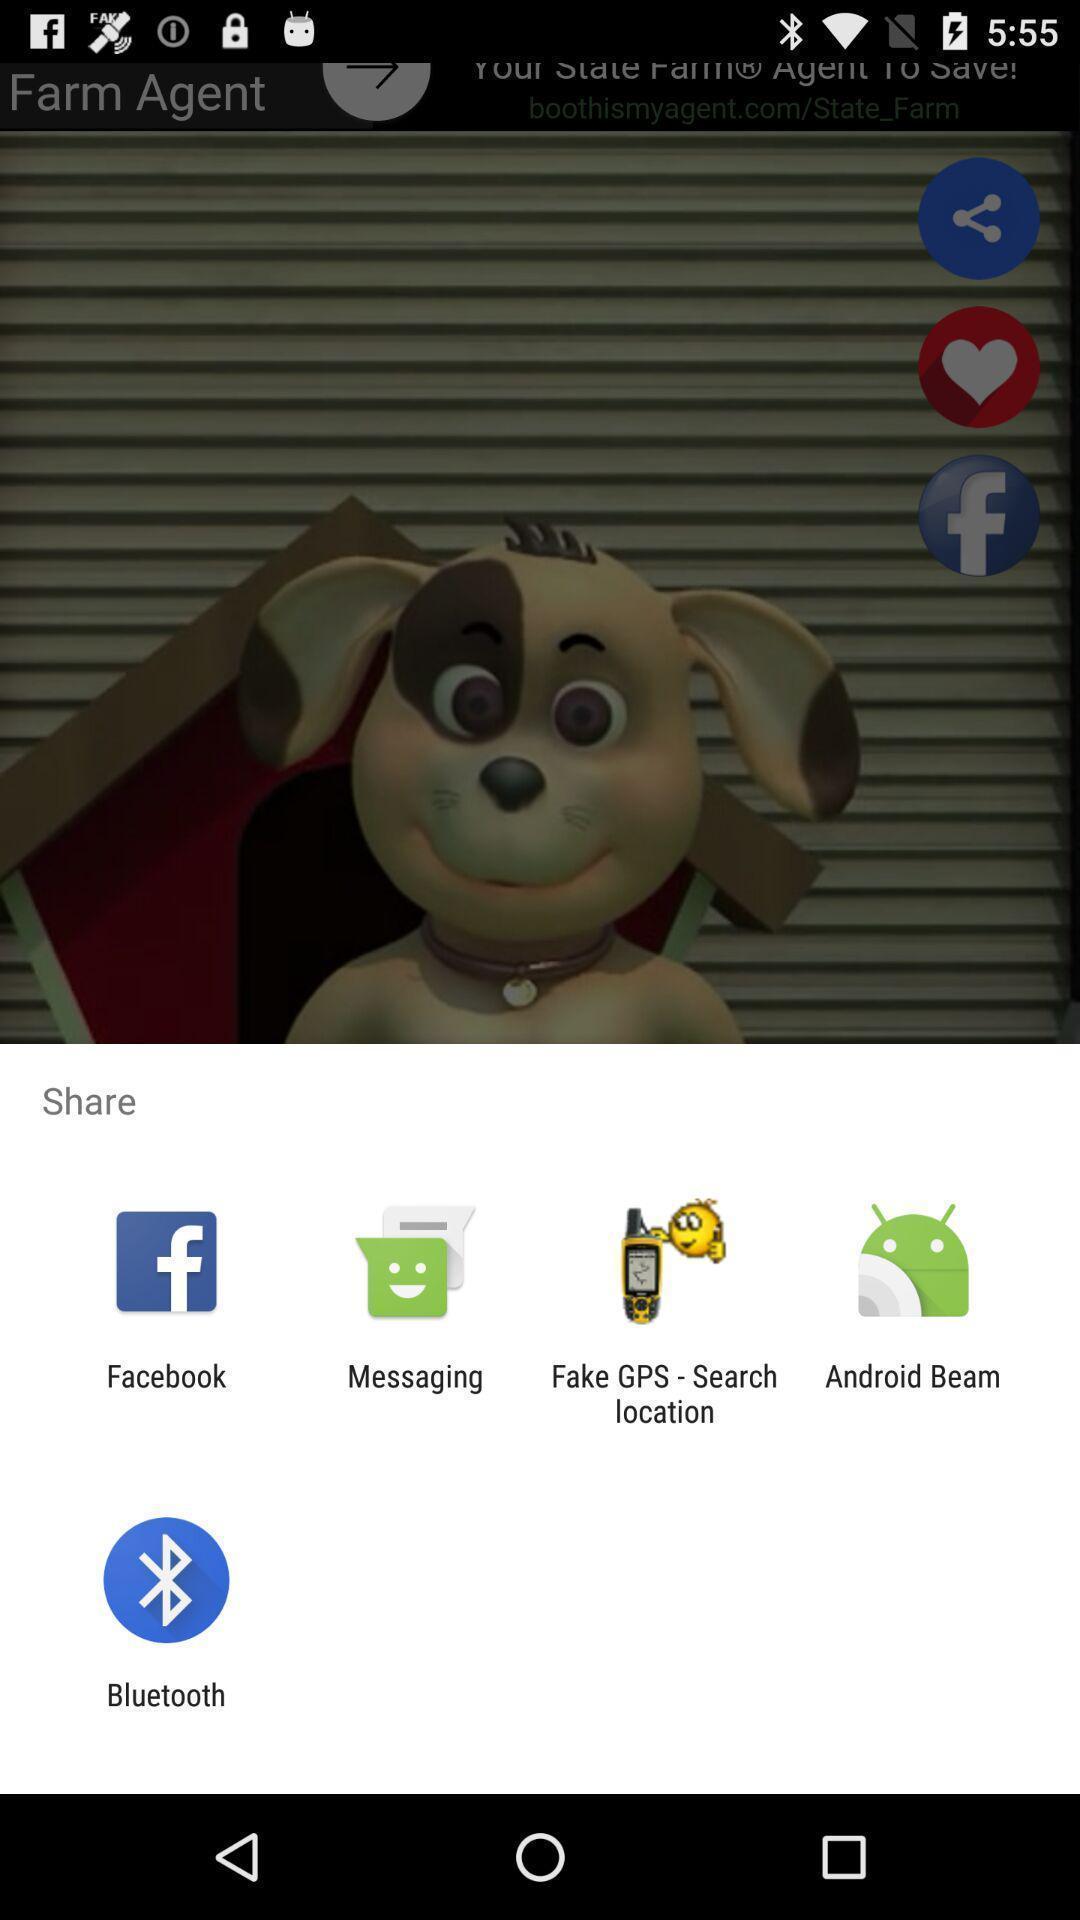Explain what's happening in this screen capture. Widget displaying different sharing applications. 